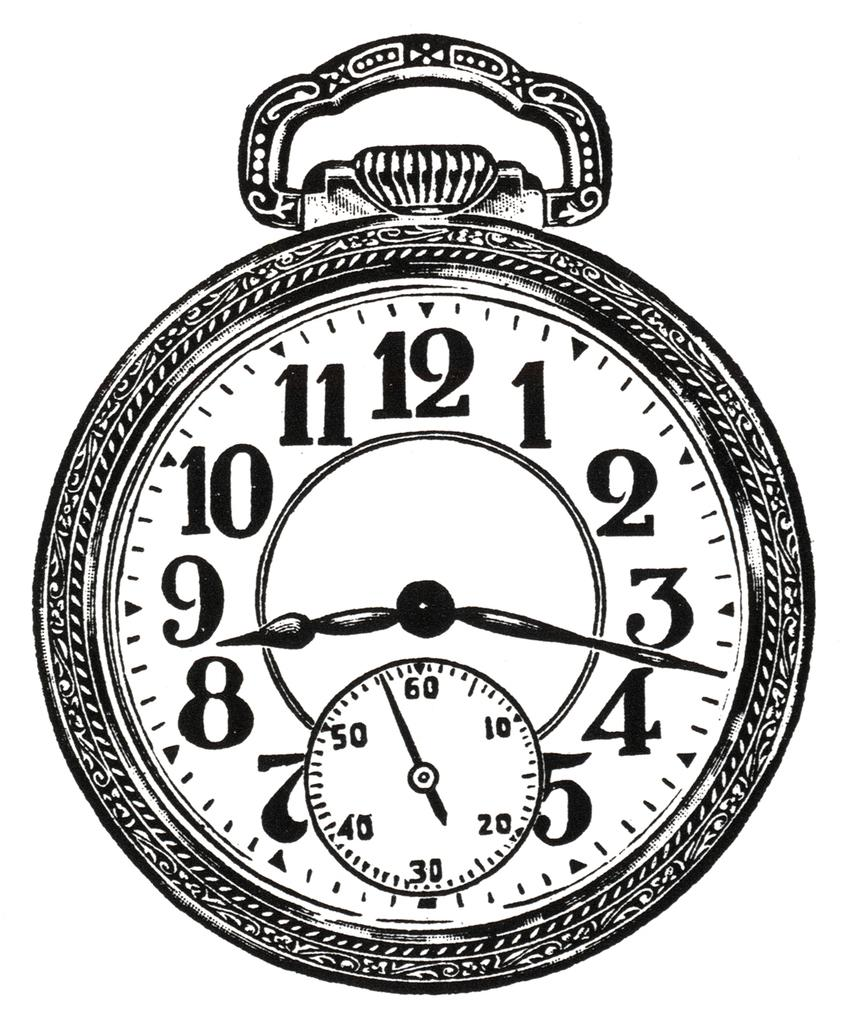Provide a one-sentence caption for the provided image. The time on the clock is 8:17 P.M. 